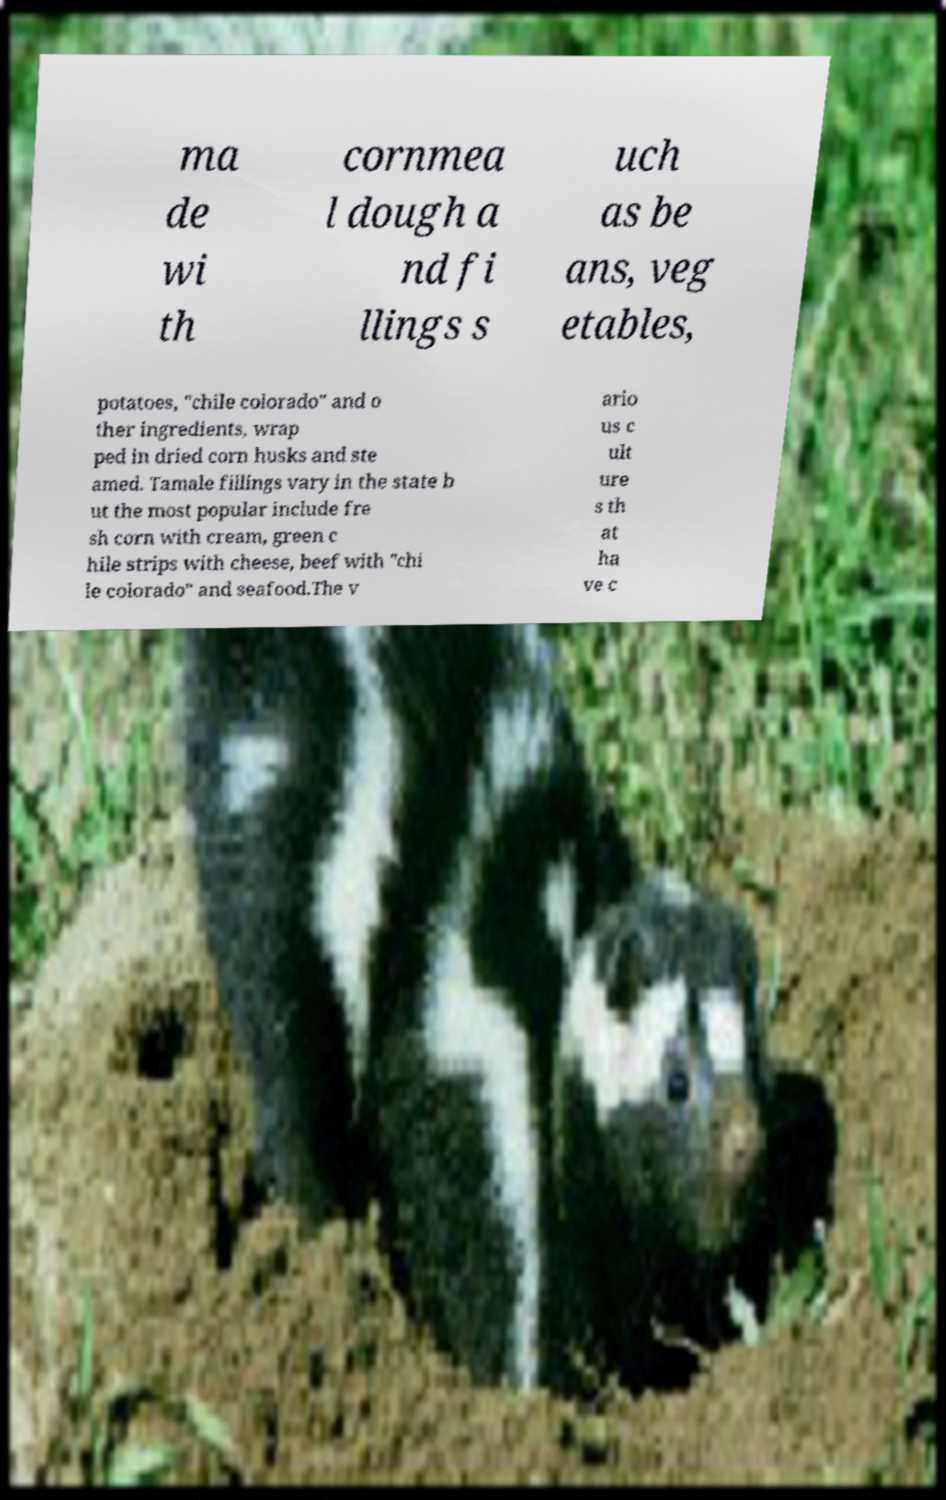What messages or text are displayed in this image? I need them in a readable, typed format. ma de wi th cornmea l dough a nd fi llings s uch as be ans, veg etables, potatoes, "chile colorado" and o ther ingredients, wrap ped in dried corn husks and ste amed. Tamale fillings vary in the state b ut the most popular include fre sh corn with cream, green c hile strips with cheese, beef with "chi le colorado" and seafood.The v ario us c ult ure s th at ha ve c 